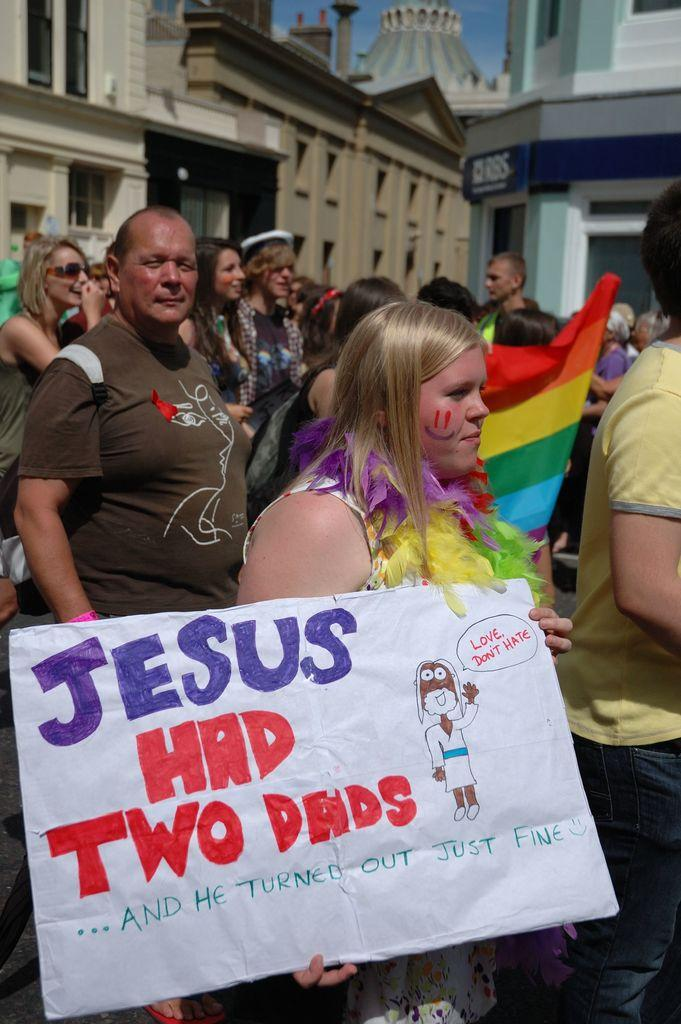What is the main subject of the image? The main subject of the image is a group of people. Where are the people located in the image? The group of people is in front of buildings. Can you describe the person in the middle of the image? The person in the middle is holding a placard. How is the person holding the placard? The person is holding the placard with her hands. What type of bit can be seen in the person's vein in the image? There is no bit or vein visible in the image; it features a group of people with a person holding a placard. 